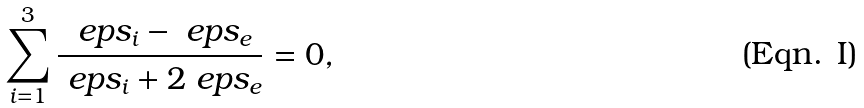<formula> <loc_0><loc_0><loc_500><loc_500>\sum _ { i = 1 } ^ { 3 } \frac { \ e p s _ { i } - \ e p s _ { e } } { \ e p s _ { i } + 2 \ e p s _ { e } } = 0 ,</formula> 